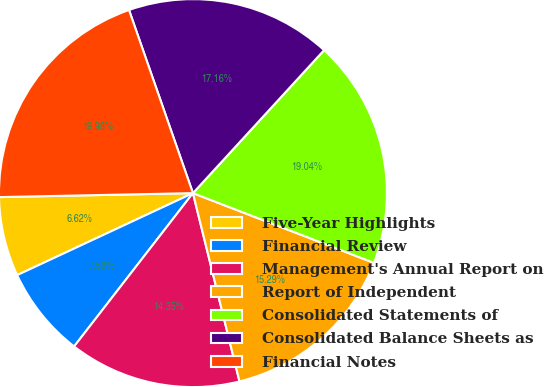Convert chart to OTSL. <chart><loc_0><loc_0><loc_500><loc_500><pie_chart><fcel>Five-Year Highlights<fcel>Financial Review<fcel>Management's Annual Report on<fcel>Report of Independent<fcel>Consolidated Statements of<fcel>Consolidated Balance Sheets as<fcel>Financial Notes<nl><fcel>6.62%<fcel>7.56%<fcel>14.35%<fcel>15.29%<fcel>19.04%<fcel>17.16%<fcel>19.98%<nl></chart> 